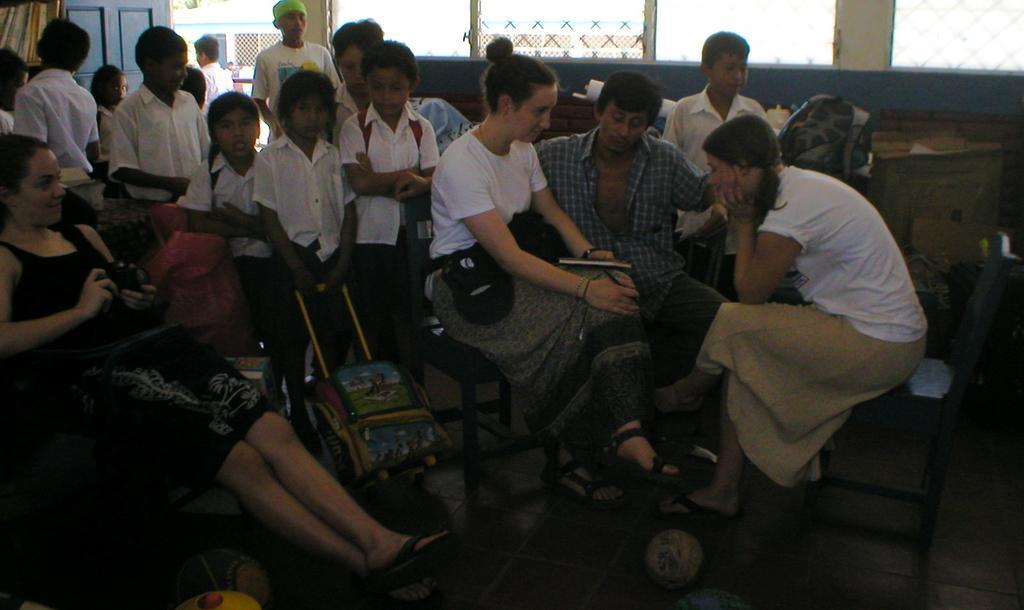How would you summarize this image in a sentence or two? In this image we can see group of people sitting on the chairs. One woman is carrying a bag on her holding a book in her hand. To the left side of the image we can see a woman sitting on chair holding a camera in her hand. In the background we can see group of children standing. One girl is holding a bag with her hand and a door. 